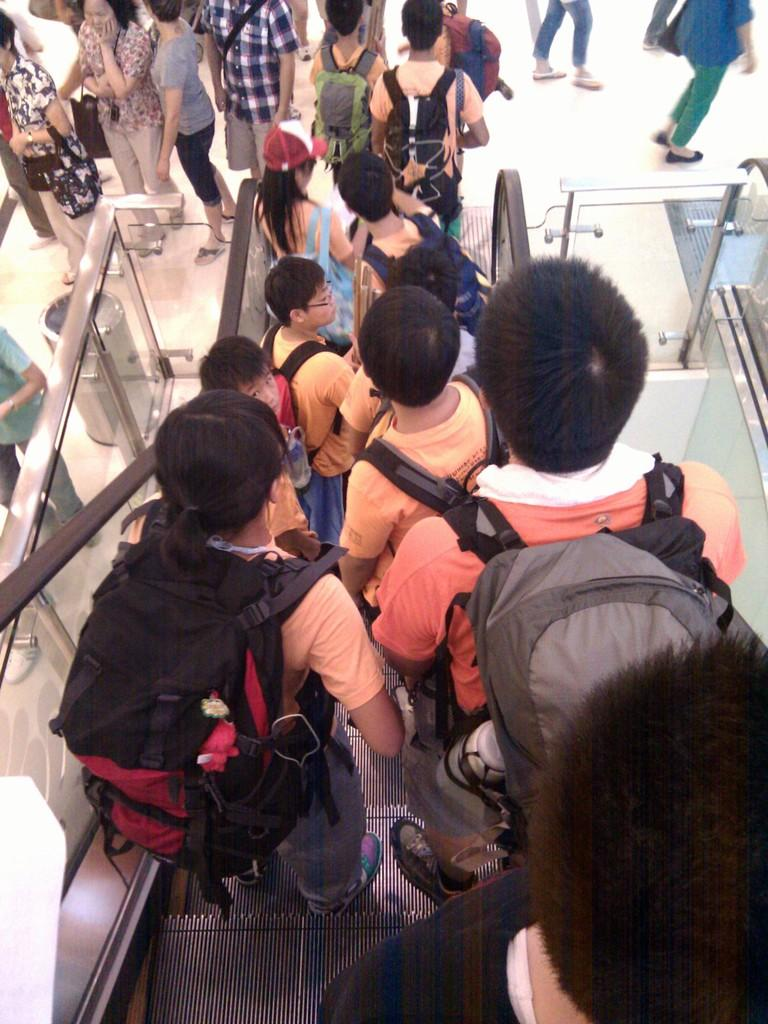What are the people in the image doing? The people in the image are standing on an escalator. What are some people wearing in the image? Some people are wearing bags in the image. Where are the people standing at the top of the escalator? The people standing at the top of the escalator are at the top of the escalator. What can be seen near the escalator in the image? There is a bin near the escalator in the image. What type of nerve can be seen in the image? There is no nerve present in the image; it features people standing on an escalator. Can you tell me how many toads are visible in the image? There are no toads visible in the image. 